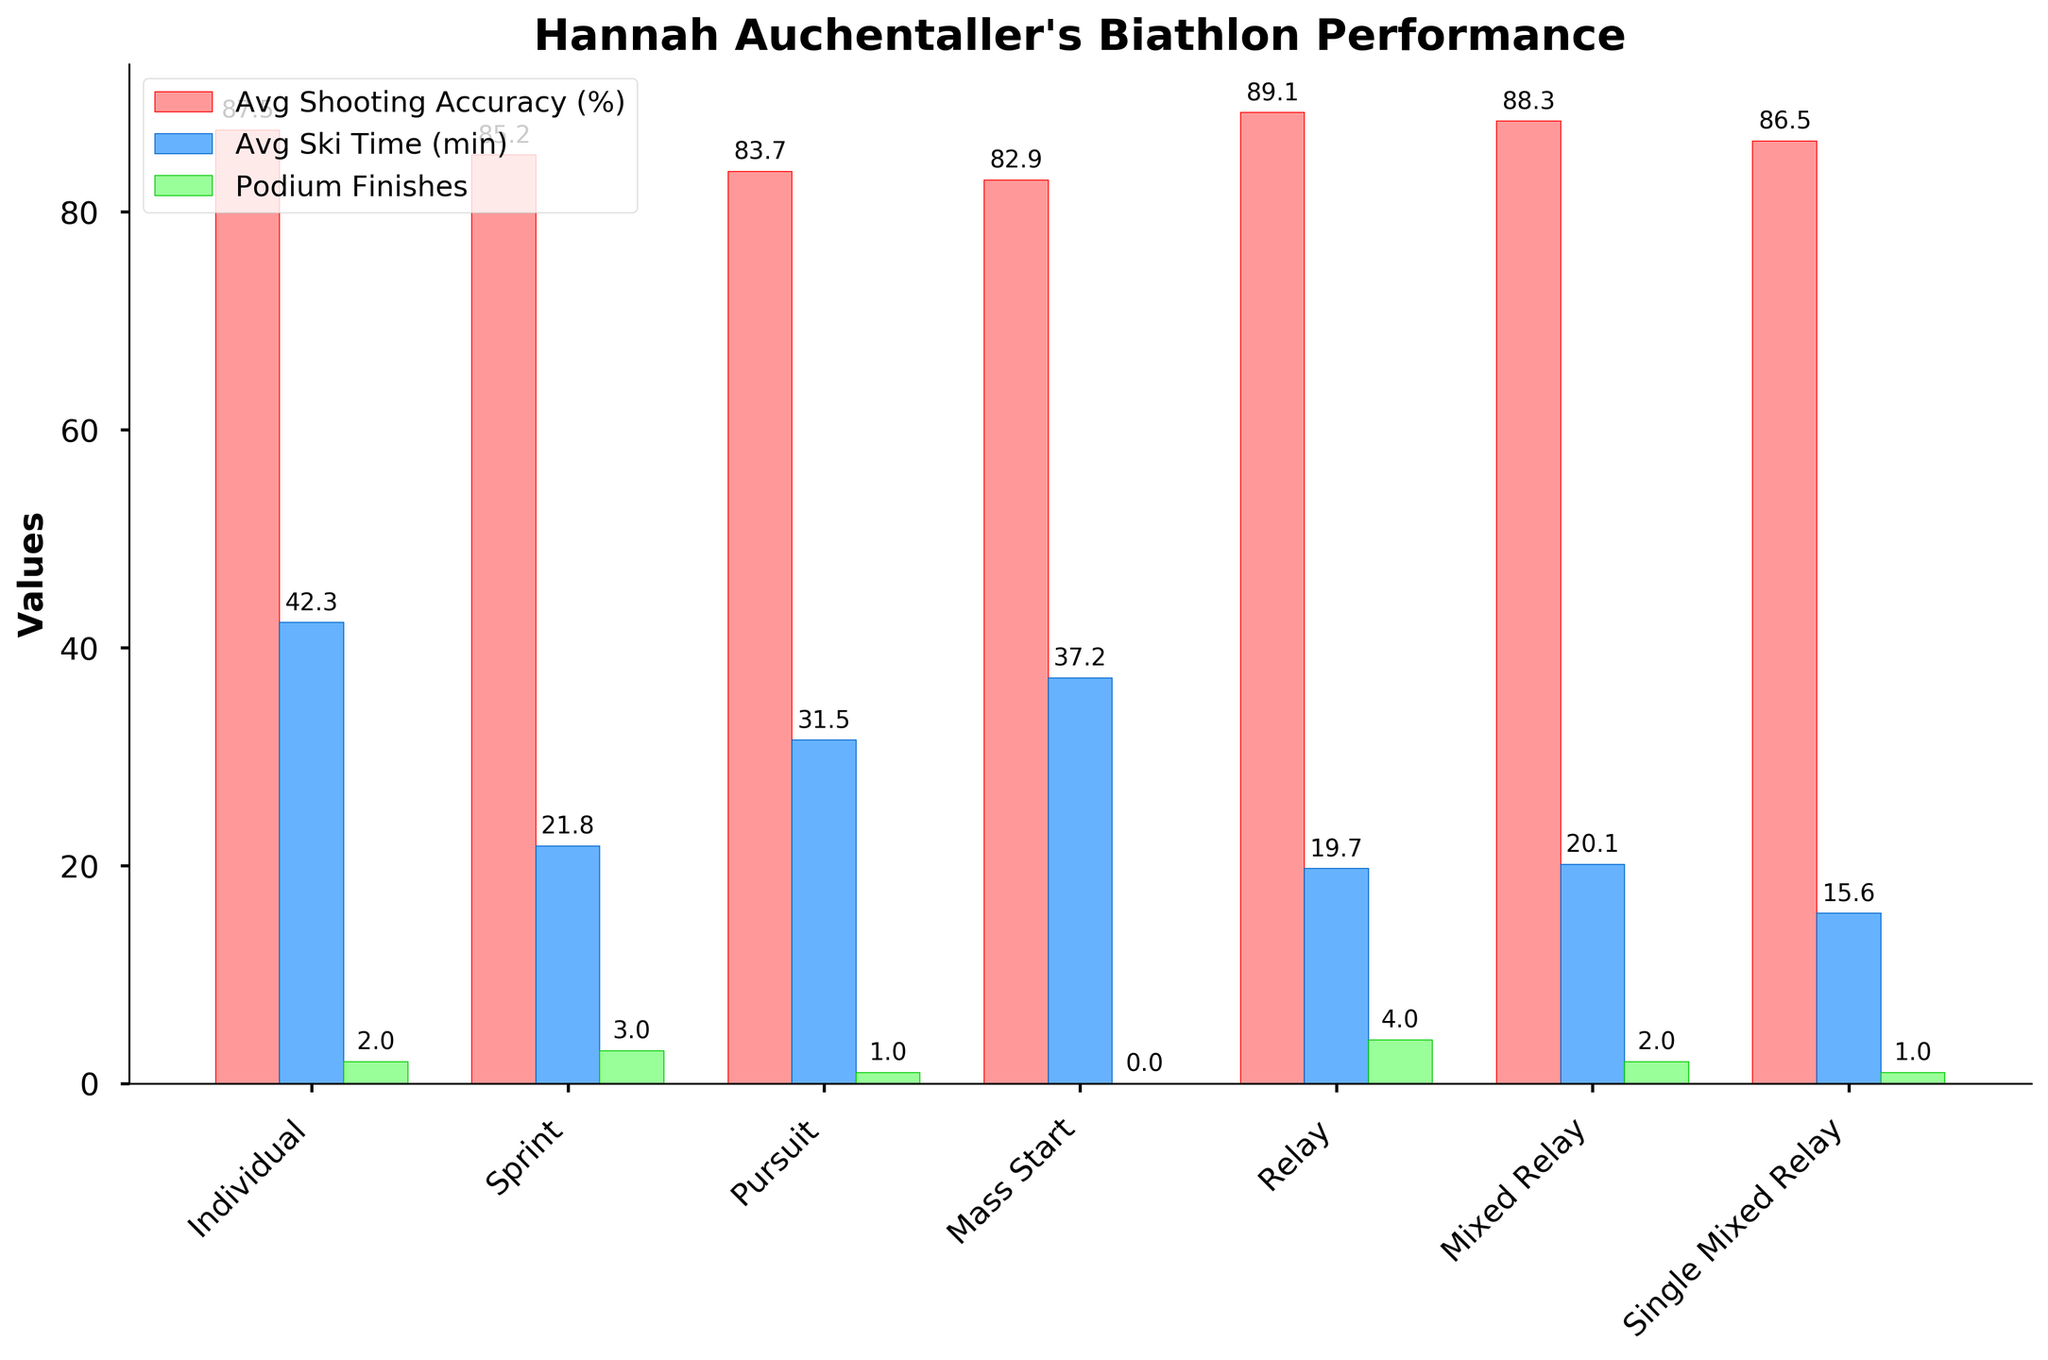What is the event type with the highest average shooting accuracy? Identify which bar representing 'Average Shooting Accuracy (%)' is the tallest. The tallest bar in the red color segment represents the 'Relay' event with an accuracy of 89.1%.
Answer: Relay Which event type has the lowest average ski time? Compare the heights of the blue bars that correspond to 'Average Ski Time (min)'. The shortest bar in the blue color segment represents the 'Single Mixed Relay' event with a ski time of 15.6 minutes.
Answer: Single Mixed Relay How many more podium finishes does Hannah have in the 'Relay' event compared to the 'Mass Start' event? Determine the difference in heights between the green bars for 'Relay' (with a value of 4) and 'Mass Start' (with a value of 0). 4 - 0 = 4
Answer: 4 Which event type has the smallest gap between its average shooting accuracy and average ski time? Calculate the difference between the 'Average Shooting Accuracy (%)' and 'Average Ski Time (min)' for each event type. The smallest gap is in the 'Single Mixed Relay' event type where the shooting accuracy is 86.5% and ski time is 15.6 minutes, resulting in a gap of 70.9.
Answer: Single Mixed Relay Is there any event where the number of podium finishes is directly proportional to the shooting accuracy? An exact proportional relationship would indicate that as shooting accuracy increases, so would the podium finishes. Assessing the bars, the relationship doesn’t appear directly proportional in any event type. For example, 'Relay' has high accuracy and high podium finishes, while 'Mass Start' has low accuracy and no podium finishes.
Answer: No In which event type is Hannah’s average shooting accuracy closest to the average ski time? Compare the shooting accuracy and ski time for each event type to see the smallest difference between the two. For the 'Single Mixed Relay', the shooting accuracy is 86.5% and the ski time is 15.6 minutes, making the relative difference the smallest.
Answer: Single Mixed Relay How many event types have an average shooting accuracy greater than 85%? Look at the heights of the red bars representing 'Average Shooting Accuracy (%)' and count those with values greater than 85%. The event types that meet this criterion are 'Individual', 'Relay', 'Mixed Relay', and 'Single Mixed Relay'.
Answer: 4 Which event type has the largest combined total of shooting accuracy and ski time? Calculate the sum of 'Average Shooting Accuracy (%)' and 'Average Ski Time (min)' for each event type. The highest total is for the 'Individual' event type (87.5 + 42.3 = 129.8).
Answer: Individual Which event types have 2 podium finishes? Identify the green bars representing 'Podium Finishes' that reach the value of 2. The event types with 2 podium finishes are 'Individual' and 'Mixed Relay'.
Answer: Individual, Mixed Relay 